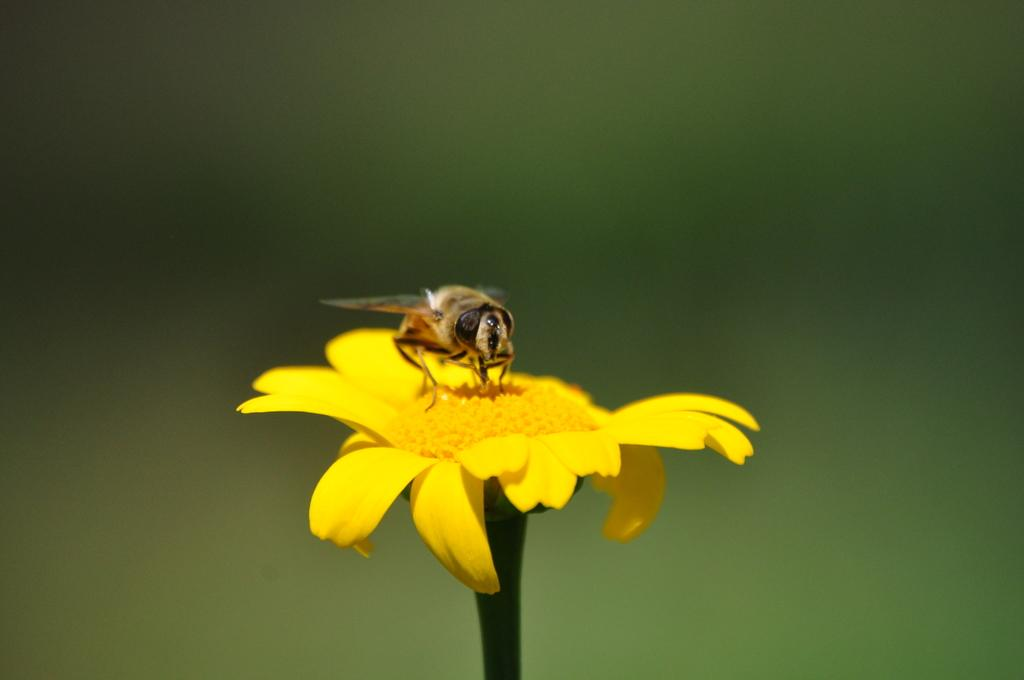What type of living organism can be seen in the image? There is an insect in the image. What type of plant is present in the image? There is a flower in the image. Can you describe the background of the image? The background of the image is blurred. What month is the committee meeting taking place in the image? There is no mention of a committee or a meeting in the image, so it is not possible to determine the month. 